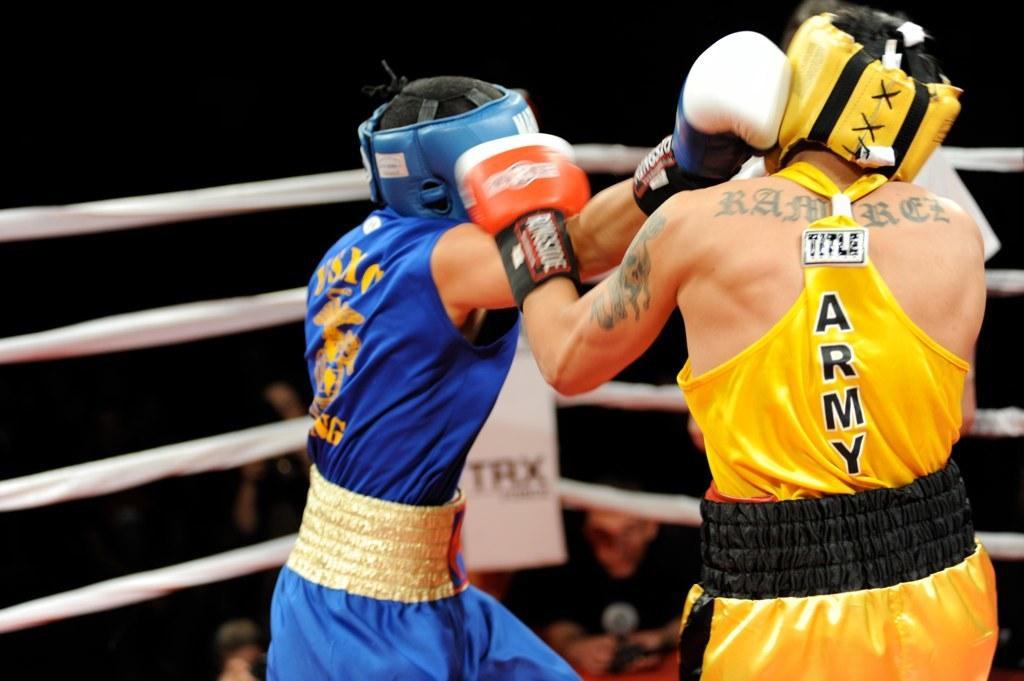Can you describe this image briefly? This picture shows boxing between two men on the ring and we see people standing. 